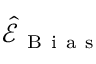<formula> <loc_0><loc_0><loc_500><loc_500>\widehat { \mathcal { E } } _ { B i a s }</formula> 